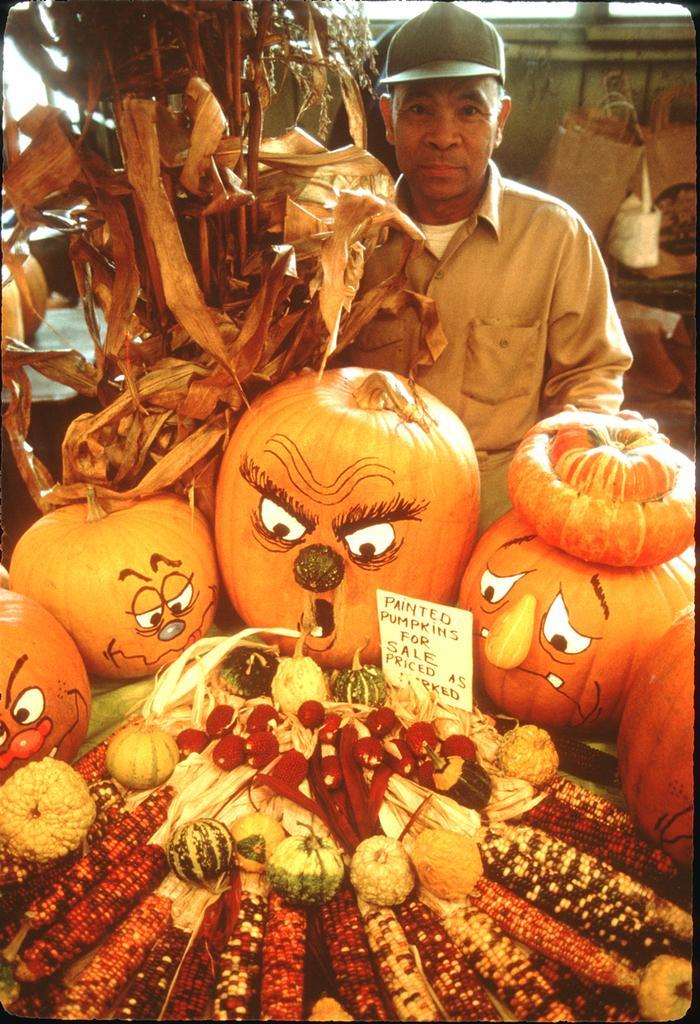Please provide a concise description of this image. In this image I can see few fruits and vegetables and I can also see the person. In the background I can see few objects. 